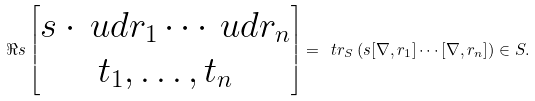Convert formula to latex. <formula><loc_0><loc_0><loc_500><loc_500>\Re s \left [ \begin{matrix} s \cdot \ u d r _ { 1 } \cdots \ u d r _ { n } \\ t _ { 1 } , \dots , t _ { n } \end{matrix} \right ] = \ t r _ { S } \left ( s [ \nabla , r _ { 1 } ] \cdots [ \nabla , r _ { n } ] \right ) \in S .</formula> 